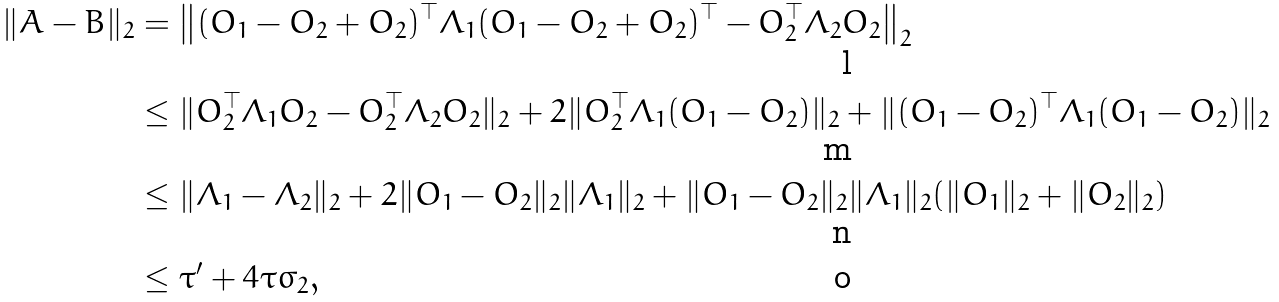Convert formula to latex. <formula><loc_0><loc_0><loc_500><loc_500>\| A - B \| _ { 2 } & = \left \| ( O _ { 1 } - O _ { 2 } + O _ { 2 } ) ^ { \top } \Lambda _ { 1 } ( O _ { 1 } - O _ { 2 } + O _ { 2 } ) ^ { \top } - O _ { 2 } ^ { \top } \Lambda _ { 2 } O _ { 2 } \right \| _ { 2 } \\ & \leq \| O _ { 2 } ^ { \top } \Lambda _ { 1 } O _ { 2 } - O _ { 2 } ^ { \top } \Lambda _ { 2 } O _ { 2 } \| _ { 2 } + 2 \| O _ { 2 } ^ { \top } \Lambda _ { 1 } ( O _ { 1 } - O _ { 2 } ) \| _ { 2 } + \| ( O _ { 1 } - O _ { 2 } ) ^ { \top } \Lambda _ { 1 } ( O _ { 1 } - O _ { 2 } ) \| _ { 2 } \\ & \leq \| \Lambda _ { 1 } - \Lambda _ { 2 } \| _ { 2 } + 2 \| O _ { 1 } - O _ { 2 } \| _ { 2 } \| \Lambda _ { 1 } \| _ { 2 } + \| O _ { 1 } - O _ { 2 } \| _ { 2 } \| \Lambda _ { 1 } \| _ { 2 } ( \| O _ { 1 } \| _ { 2 } + \| O _ { 2 } \| _ { 2 } ) \\ & \leq \tau ^ { \prime } + 4 \tau \sigma _ { 2 } ,</formula> 